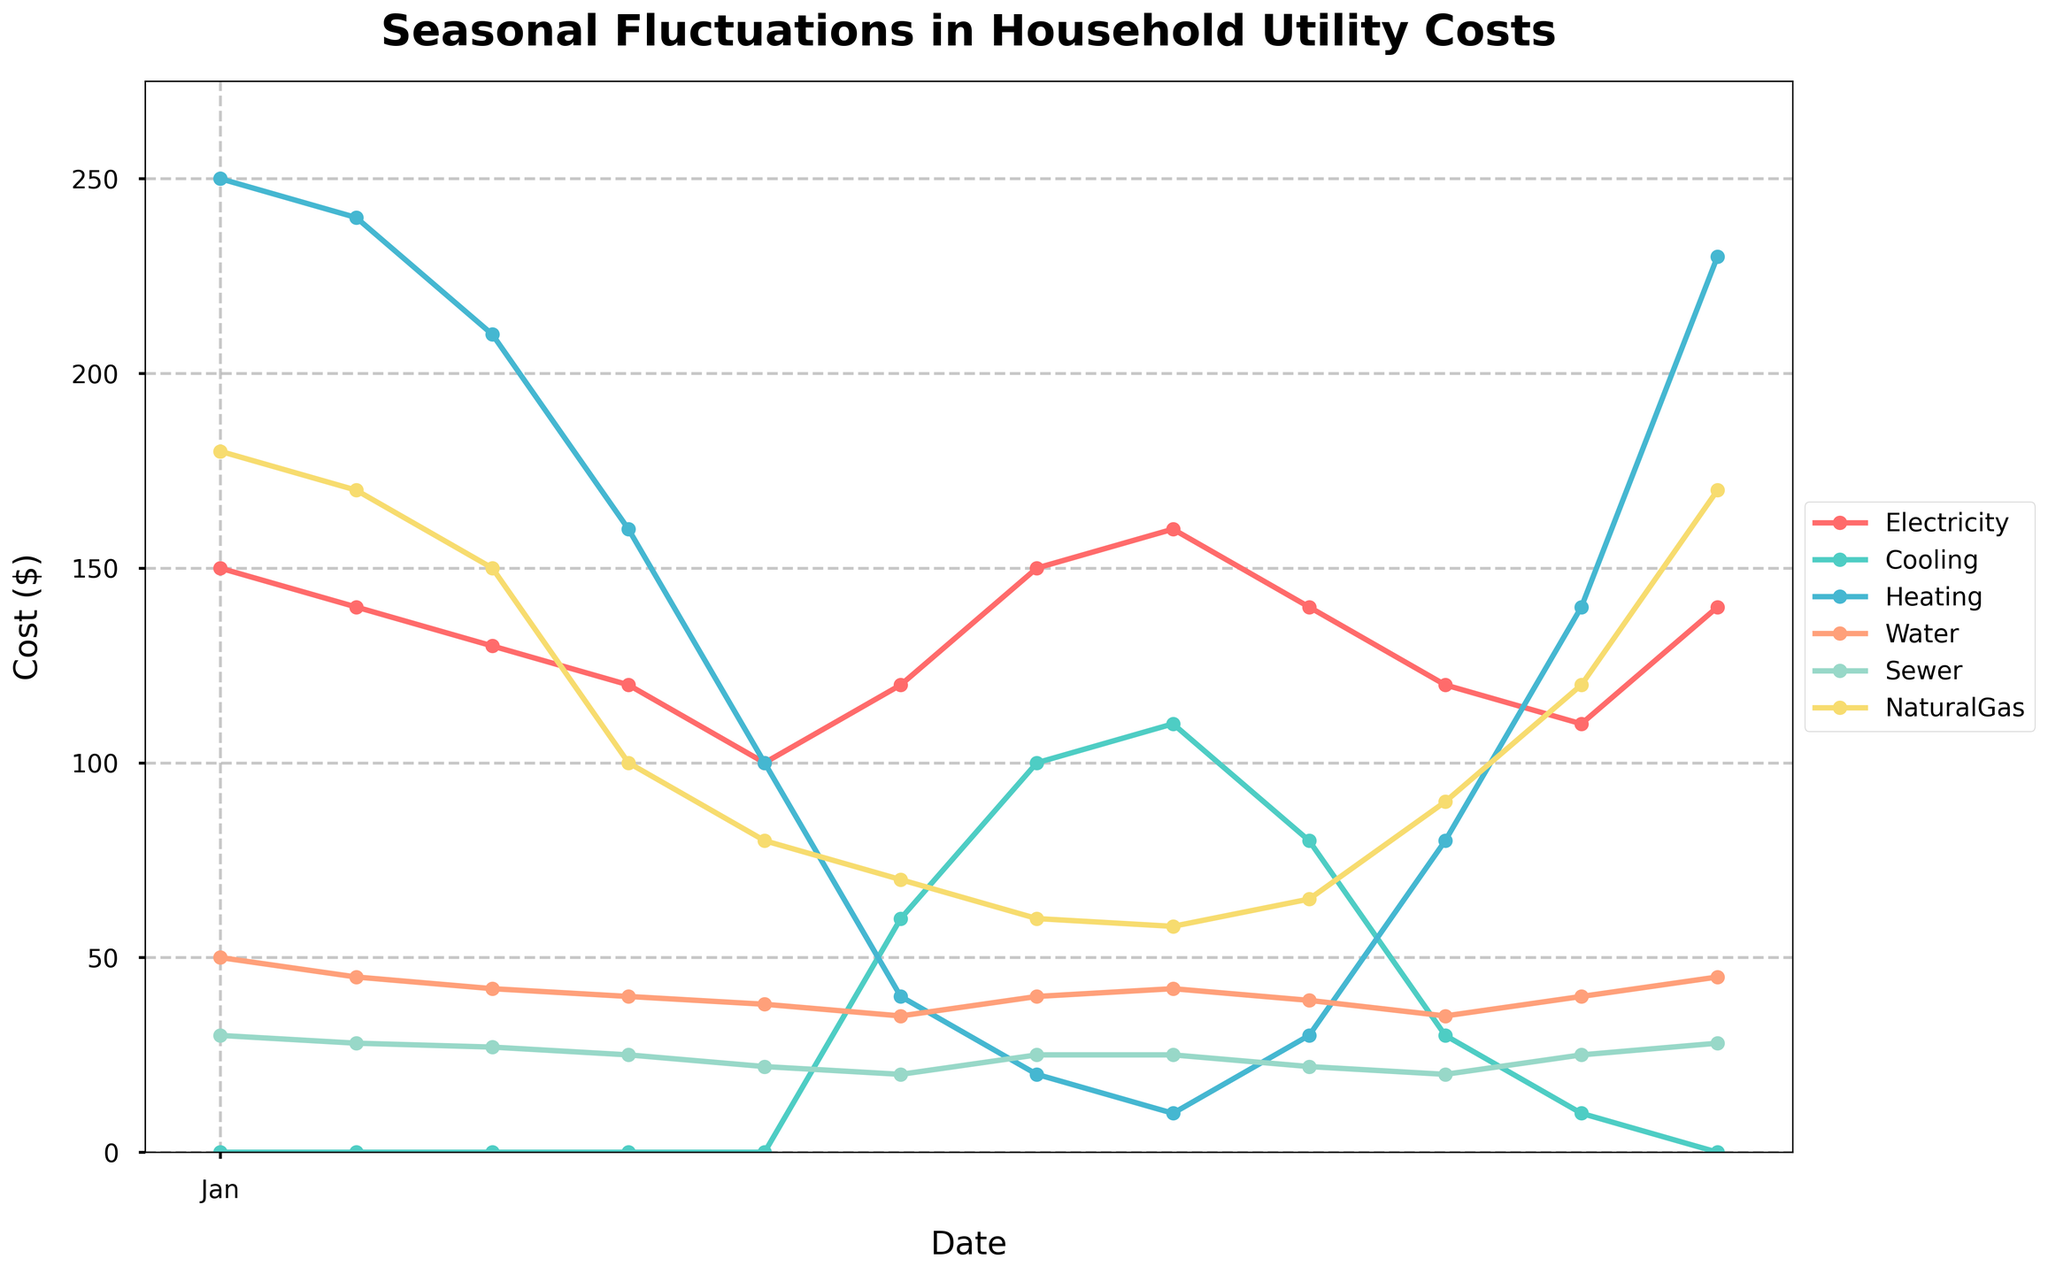What is the title of the figure? The title of the figure is clearly indicated at the top of the plot. It is written in bold, larger font size, making it easily noticeable.
Answer: Seasonal Fluctuations in Household Utility Costs Which month has the highest cooling cost? To find the highest cooling cost, look at the peaks in the cooling cost line, marked in distinct color with markers at each month. The highest marker is observed in August.
Answer: August What is the total household utility cost in January for all categories combined? To calculate the total cost in January, sum up the values of each category for January: Electricity (150) + Cooling (0) + Heating (250) + Water (50) + Sewer (30) + Natural Gas (180).
Answer: 660 Compare electricity costs in July and December. Which one is higher? By observing the electricity cost line, find the points corresponding to July and December. The values are 150 in both months, indicating they are equal.
Answer: Equal Which utility costs show a notable decrease from August to September? Examine the line for each utility cost between August and September. Notice the cooling cost line drops significantly from 110 to 80, marking a notable decrease.
Answer: Cooling In which month does heating cost start showing significant increases? Look at the heating cost line and identify the month where it starts rising sharply. A significant increase is noticeable from September to October.
Answer: October How does water cost fluctuate throughout the year? Observe the line representing water costs across all months. The water cost line shows smaller variations, maintaining a relatively stable range between 35 and 50 dollars.
Answer: Relatively stable What is the average electricity cost over the year? Calculate the average by summing the monthly electricity costs and dividing by the number of months: (150 + 140 + 130 + 120 + 100 + 120 + 150 + 160 + 140 + 120 + 110 + 140) / 12. The sum is 1580, and dividing by 12 gives approximately 131.67.
Answer: 131.67 Which month has the lowest natural gas cost, and what is the cost? By looking at the natural gas line, the lowest point occurs in August with a cost of 58 dollars.
Answer: August, 58 How do the heating costs change from March to April? Find the points corresponding to March and April on the heating cost line. The cost decreases from 210 in March to 160 in April.
Answer: Decrease 